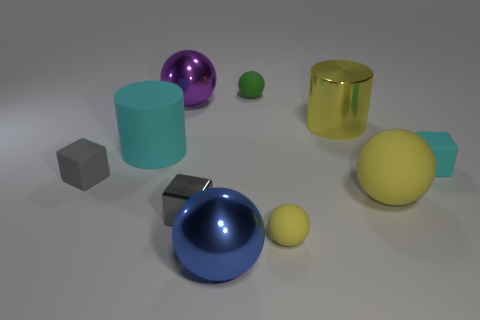What shape is the matte object that is both left of the tiny yellow ball and to the right of the large cyan matte cylinder?
Give a very brief answer. Sphere. Are the big cyan thing and the cyan block made of the same material?
Offer a terse response. Yes. There is a rubber cylinder that is the same size as the purple shiny object; what color is it?
Give a very brief answer. Cyan. The metal thing that is in front of the purple object and to the left of the blue thing is what color?
Offer a very short reply. Gray. There is a shiny thing that is the same color as the large matte ball; what size is it?
Give a very brief answer. Large. What shape is the matte thing that is the same color as the matte cylinder?
Your response must be concise. Cube. There is a metallic sphere that is behind the big blue sphere on the left side of the object that is behind the large purple ball; how big is it?
Offer a very short reply. Large. What is the material of the big cyan cylinder?
Offer a terse response. Rubber. Do the cyan cube and the gray object on the right side of the large purple thing have the same material?
Offer a terse response. No. Is there any other thing that is the same color as the tiny shiny block?
Provide a short and direct response. Yes. 